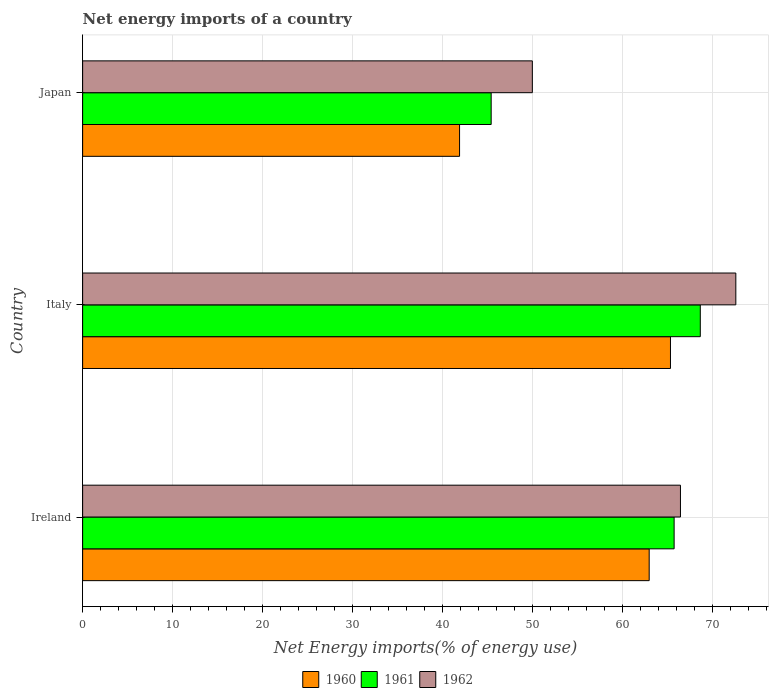How many groups of bars are there?
Offer a terse response. 3. Are the number of bars per tick equal to the number of legend labels?
Keep it short and to the point. Yes. Are the number of bars on each tick of the Y-axis equal?
Offer a very short reply. Yes. In how many cases, is the number of bars for a given country not equal to the number of legend labels?
Offer a very short reply. 0. What is the net energy imports in 1962 in Ireland?
Offer a very short reply. 66.43. Across all countries, what is the maximum net energy imports in 1961?
Your response must be concise. 68.63. Across all countries, what is the minimum net energy imports in 1962?
Provide a short and direct response. 49.97. What is the total net energy imports in 1962 in the graph?
Make the answer very short. 188.97. What is the difference between the net energy imports in 1961 in Ireland and that in Italy?
Your answer should be very brief. -2.91. What is the difference between the net energy imports in 1961 in Italy and the net energy imports in 1960 in Japan?
Keep it short and to the point. 26.75. What is the average net energy imports in 1962 per country?
Offer a terse response. 62.99. What is the difference between the net energy imports in 1961 and net energy imports in 1960 in Ireland?
Offer a very short reply. 2.77. What is the ratio of the net energy imports in 1960 in Ireland to that in Italy?
Give a very brief answer. 0.96. Is the net energy imports in 1961 in Ireland less than that in Japan?
Provide a succinct answer. No. Is the difference between the net energy imports in 1961 in Ireland and Italy greater than the difference between the net energy imports in 1960 in Ireland and Italy?
Provide a short and direct response. No. What is the difference between the highest and the second highest net energy imports in 1960?
Provide a short and direct response. 2.36. What is the difference between the highest and the lowest net energy imports in 1960?
Provide a succinct answer. 23.43. Is the sum of the net energy imports in 1961 in Italy and Japan greater than the maximum net energy imports in 1960 across all countries?
Provide a succinct answer. Yes. What does the 1st bar from the top in Ireland represents?
Offer a very short reply. 1962. Is it the case that in every country, the sum of the net energy imports in 1961 and net energy imports in 1960 is greater than the net energy imports in 1962?
Provide a succinct answer. Yes. How many bars are there?
Provide a succinct answer. 9. Are the values on the major ticks of X-axis written in scientific E-notation?
Provide a short and direct response. No. Does the graph contain any zero values?
Give a very brief answer. No. Does the graph contain grids?
Make the answer very short. Yes. What is the title of the graph?
Provide a short and direct response. Net energy imports of a country. Does "1994" appear as one of the legend labels in the graph?
Provide a short and direct response. No. What is the label or title of the X-axis?
Ensure brevity in your answer.  Net Energy imports(% of energy use). What is the Net Energy imports(% of energy use) of 1960 in Ireland?
Provide a short and direct response. 62.95. What is the Net Energy imports(% of energy use) of 1961 in Ireland?
Your answer should be very brief. 65.72. What is the Net Energy imports(% of energy use) of 1962 in Ireland?
Ensure brevity in your answer.  66.43. What is the Net Energy imports(% of energy use) in 1960 in Italy?
Your response must be concise. 65.32. What is the Net Energy imports(% of energy use) of 1961 in Italy?
Provide a succinct answer. 68.63. What is the Net Energy imports(% of energy use) in 1962 in Italy?
Offer a terse response. 72.58. What is the Net Energy imports(% of energy use) of 1960 in Japan?
Give a very brief answer. 41.88. What is the Net Energy imports(% of energy use) in 1961 in Japan?
Your answer should be compact. 45.39. What is the Net Energy imports(% of energy use) of 1962 in Japan?
Your answer should be compact. 49.97. Across all countries, what is the maximum Net Energy imports(% of energy use) in 1960?
Provide a succinct answer. 65.32. Across all countries, what is the maximum Net Energy imports(% of energy use) in 1961?
Ensure brevity in your answer.  68.63. Across all countries, what is the maximum Net Energy imports(% of energy use) in 1962?
Make the answer very short. 72.58. Across all countries, what is the minimum Net Energy imports(% of energy use) in 1960?
Give a very brief answer. 41.88. Across all countries, what is the minimum Net Energy imports(% of energy use) of 1961?
Keep it short and to the point. 45.39. Across all countries, what is the minimum Net Energy imports(% of energy use) in 1962?
Keep it short and to the point. 49.97. What is the total Net Energy imports(% of energy use) in 1960 in the graph?
Provide a short and direct response. 170.15. What is the total Net Energy imports(% of energy use) in 1961 in the graph?
Make the answer very short. 179.75. What is the total Net Energy imports(% of energy use) in 1962 in the graph?
Provide a short and direct response. 188.97. What is the difference between the Net Energy imports(% of energy use) of 1960 in Ireland and that in Italy?
Offer a terse response. -2.36. What is the difference between the Net Energy imports(% of energy use) in 1961 in Ireland and that in Italy?
Ensure brevity in your answer.  -2.91. What is the difference between the Net Energy imports(% of energy use) of 1962 in Ireland and that in Italy?
Your response must be concise. -6.15. What is the difference between the Net Energy imports(% of energy use) of 1960 in Ireland and that in Japan?
Offer a terse response. 21.07. What is the difference between the Net Energy imports(% of energy use) of 1961 in Ireland and that in Japan?
Provide a short and direct response. 20.33. What is the difference between the Net Energy imports(% of energy use) in 1962 in Ireland and that in Japan?
Your response must be concise. 16.46. What is the difference between the Net Energy imports(% of energy use) in 1960 in Italy and that in Japan?
Offer a very short reply. 23.43. What is the difference between the Net Energy imports(% of energy use) in 1961 in Italy and that in Japan?
Keep it short and to the point. 23.24. What is the difference between the Net Energy imports(% of energy use) in 1962 in Italy and that in Japan?
Offer a very short reply. 22.61. What is the difference between the Net Energy imports(% of energy use) in 1960 in Ireland and the Net Energy imports(% of energy use) in 1961 in Italy?
Give a very brief answer. -5.68. What is the difference between the Net Energy imports(% of energy use) in 1960 in Ireland and the Net Energy imports(% of energy use) in 1962 in Italy?
Your answer should be very brief. -9.63. What is the difference between the Net Energy imports(% of energy use) of 1961 in Ireland and the Net Energy imports(% of energy use) of 1962 in Italy?
Your response must be concise. -6.86. What is the difference between the Net Energy imports(% of energy use) in 1960 in Ireland and the Net Energy imports(% of energy use) in 1961 in Japan?
Your answer should be very brief. 17.56. What is the difference between the Net Energy imports(% of energy use) in 1960 in Ireland and the Net Energy imports(% of energy use) in 1962 in Japan?
Your answer should be compact. 12.98. What is the difference between the Net Energy imports(% of energy use) of 1961 in Ireland and the Net Energy imports(% of energy use) of 1962 in Japan?
Your answer should be very brief. 15.75. What is the difference between the Net Energy imports(% of energy use) in 1960 in Italy and the Net Energy imports(% of energy use) in 1961 in Japan?
Keep it short and to the point. 19.92. What is the difference between the Net Energy imports(% of energy use) in 1960 in Italy and the Net Energy imports(% of energy use) in 1962 in Japan?
Ensure brevity in your answer.  15.35. What is the difference between the Net Energy imports(% of energy use) of 1961 in Italy and the Net Energy imports(% of energy use) of 1962 in Japan?
Provide a succinct answer. 18.66. What is the average Net Energy imports(% of energy use) of 1960 per country?
Your answer should be compact. 56.72. What is the average Net Energy imports(% of energy use) of 1961 per country?
Provide a succinct answer. 59.92. What is the average Net Energy imports(% of energy use) of 1962 per country?
Provide a short and direct response. 62.99. What is the difference between the Net Energy imports(% of energy use) of 1960 and Net Energy imports(% of energy use) of 1961 in Ireland?
Offer a very short reply. -2.77. What is the difference between the Net Energy imports(% of energy use) of 1960 and Net Energy imports(% of energy use) of 1962 in Ireland?
Give a very brief answer. -3.47. What is the difference between the Net Energy imports(% of energy use) in 1961 and Net Energy imports(% of energy use) in 1962 in Ireland?
Give a very brief answer. -0.7. What is the difference between the Net Energy imports(% of energy use) of 1960 and Net Energy imports(% of energy use) of 1961 in Italy?
Give a very brief answer. -3.31. What is the difference between the Net Energy imports(% of energy use) in 1960 and Net Energy imports(% of energy use) in 1962 in Italy?
Keep it short and to the point. -7.26. What is the difference between the Net Energy imports(% of energy use) of 1961 and Net Energy imports(% of energy use) of 1962 in Italy?
Keep it short and to the point. -3.95. What is the difference between the Net Energy imports(% of energy use) in 1960 and Net Energy imports(% of energy use) in 1961 in Japan?
Ensure brevity in your answer.  -3.51. What is the difference between the Net Energy imports(% of energy use) of 1960 and Net Energy imports(% of energy use) of 1962 in Japan?
Your answer should be compact. -8.09. What is the difference between the Net Energy imports(% of energy use) in 1961 and Net Energy imports(% of energy use) in 1962 in Japan?
Provide a succinct answer. -4.57. What is the ratio of the Net Energy imports(% of energy use) of 1960 in Ireland to that in Italy?
Your response must be concise. 0.96. What is the ratio of the Net Energy imports(% of energy use) of 1961 in Ireland to that in Italy?
Offer a terse response. 0.96. What is the ratio of the Net Energy imports(% of energy use) of 1962 in Ireland to that in Italy?
Provide a short and direct response. 0.92. What is the ratio of the Net Energy imports(% of energy use) in 1960 in Ireland to that in Japan?
Offer a very short reply. 1.5. What is the ratio of the Net Energy imports(% of energy use) of 1961 in Ireland to that in Japan?
Your answer should be compact. 1.45. What is the ratio of the Net Energy imports(% of energy use) of 1962 in Ireland to that in Japan?
Ensure brevity in your answer.  1.33. What is the ratio of the Net Energy imports(% of energy use) of 1960 in Italy to that in Japan?
Offer a terse response. 1.56. What is the ratio of the Net Energy imports(% of energy use) of 1961 in Italy to that in Japan?
Keep it short and to the point. 1.51. What is the ratio of the Net Energy imports(% of energy use) in 1962 in Italy to that in Japan?
Offer a terse response. 1.45. What is the difference between the highest and the second highest Net Energy imports(% of energy use) of 1960?
Offer a very short reply. 2.36. What is the difference between the highest and the second highest Net Energy imports(% of energy use) in 1961?
Your response must be concise. 2.91. What is the difference between the highest and the second highest Net Energy imports(% of energy use) of 1962?
Offer a very short reply. 6.15. What is the difference between the highest and the lowest Net Energy imports(% of energy use) of 1960?
Offer a very short reply. 23.43. What is the difference between the highest and the lowest Net Energy imports(% of energy use) of 1961?
Provide a succinct answer. 23.24. What is the difference between the highest and the lowest Net Energy imports(% of energy use) of 1962?
Keep it short and to the point. 22.61. 